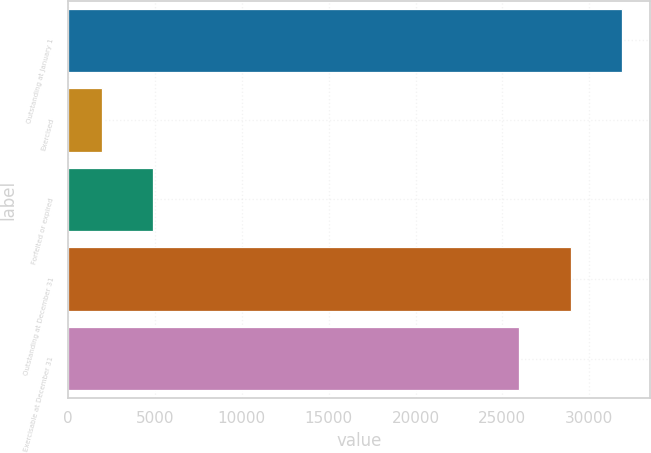<chart> <loc_0><loc_0><loc_500><loc_500><bar_chart><fcel>Outstanding at January 1<fcel>Exercised<fcel>Forfeited or expired<fcel>Outstanding at December 31<fcel>Exercisable at December 31<nl><fcel>31901<fcel>1931<fcel>4892.5<fcel>28939.5<fcel>25978<nl></chart> 